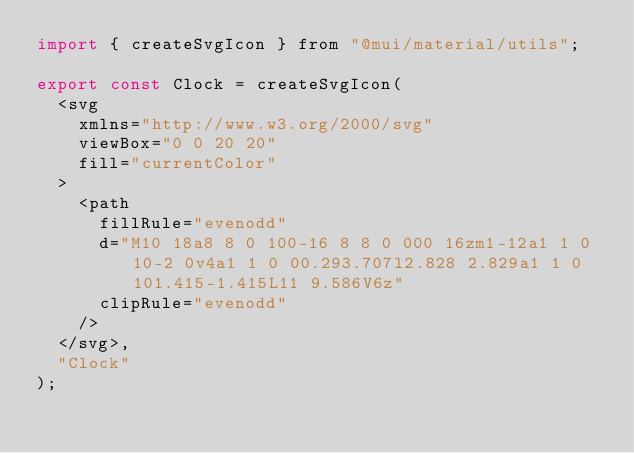<code> <loc_0><loc_0><loc_500><loc_500><_JavaScript_>import { createSvgIcon } from "@mui/material/utils";

export const Clock = createSvgIcon(
  <svg
    xmlns="http://www.w3.org/2000/svg"
    viewBox="0 0 20 20"
    fill="currentColor"
  >
    <path
      fillRule="evenodd"
      d="M10 18a8 8 0 100-16 8 8 0 000 16zm1-12a1 1 0 10-2 0v4a1 1 0 00.293.707l2.828 2.829a1 1 0 101.415-1.415L11 9.586V6z"
      clipRule="evenodd"
    />
  </svg>,
  "Clock"
);
</code> 